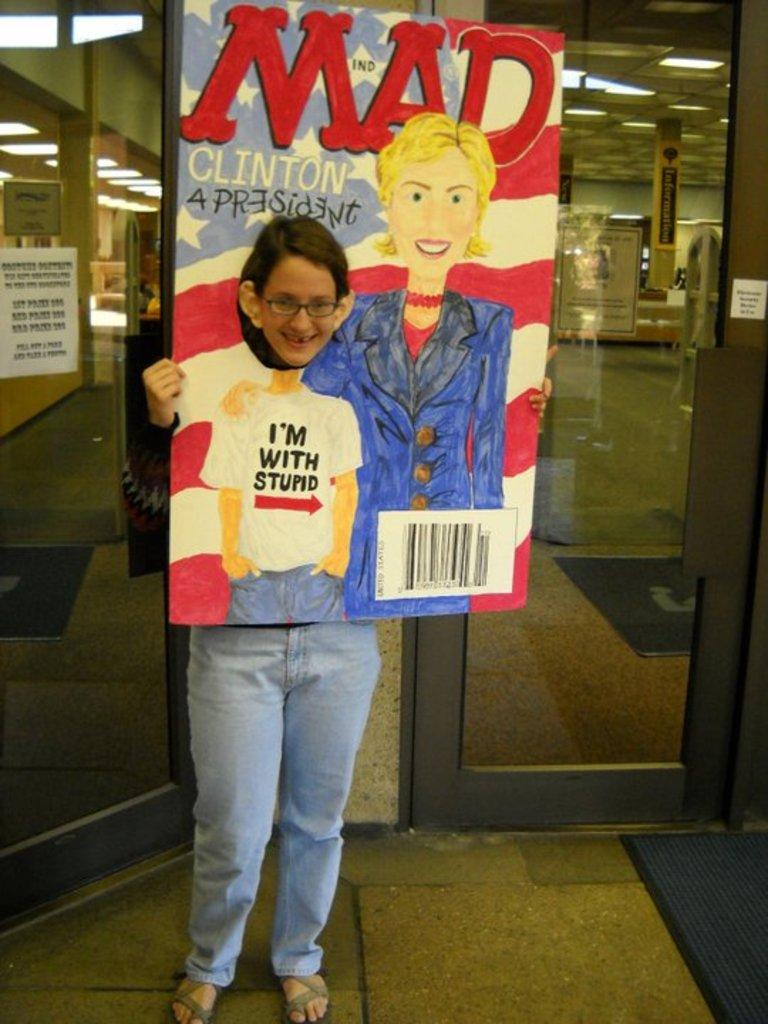What is the person in the image holding? The person is holding a board in the image. What can be seen on the board? The board has a painting and text on it. What is visible in the background of the image? There is a door in the background of the image. What is visible at the bottom of the image? There is a floor visible at the bottom of the image. What type of musical instrument is the person playing in the image? There is no musical instrument present in the image; the person is holding a board with a painting and text on it. 